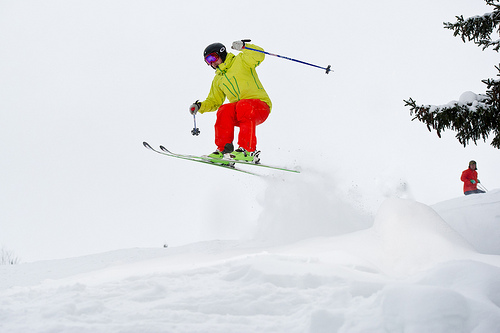Please provide a short description for this region: [0.38, 0.26, 0.45, 0.3]. The skier's goggles are perched on top of their helmet within this region, hinting at a vibrant reflection of the surroundings. 